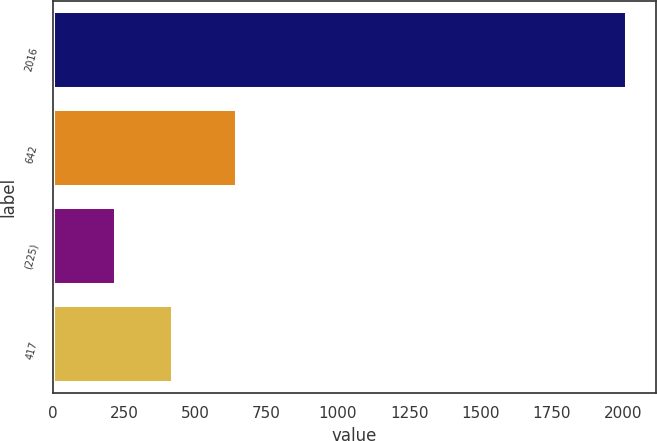Convert chart. <chart><loc_0><loc_0><loc_500><loc_500><bar_chart><fcel>2016<fcel>642<fcel>(225)<fcel>417<nl><fcel>2014<fcel>645<fcel>222<fcel>423<nl></chart> 